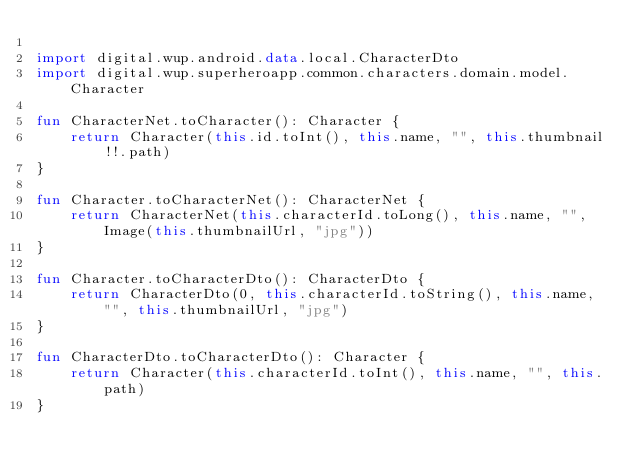Convert code to text. <code><loc_0><loc_0><loc_500><loc_500><_Kotlin_>
import digital.wup.android.data.local.CharacterDto
import digital.wup.superheroapp.common.characters.domain.model.Character

fun CharacterNet.toCharacter(): Character {
    return Character(this.id.toInt(), this.name, "", this.thumbnail!!.path)
}

fun Character.toCharacterNet(): CharacterNet {
    return CharacterNet(this.characterId.toLong(), this.name, "", Image(this.thumbnailUrl, "jpg"))
}

fun Character.toCharacterDto(): CharacterDto {
    return CharacterDto(0, this.characterId.toString(), this.name, "", this.thumbnailUrl, "jpg")
}

fun CharacterDto.toCharacterDto(): Character {
    return Character(this.characterId.toInt(), this.name, "", this.path)
}</code> 